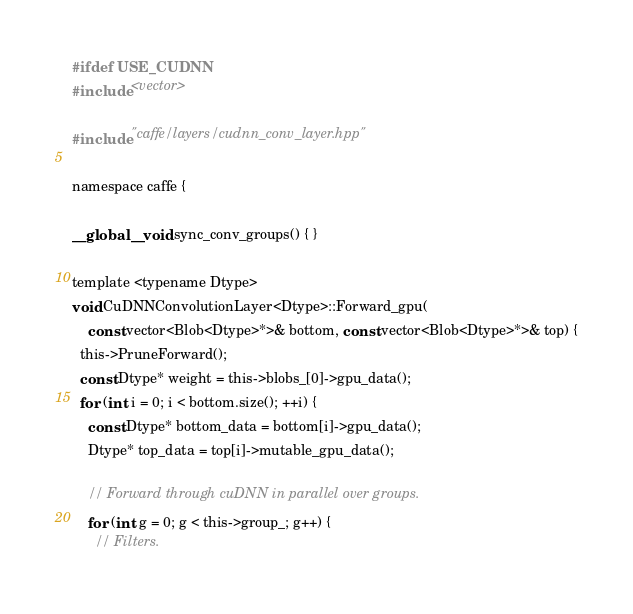Convert code to text. <code><loc_0><loc_0><loc_500><loc_500><_Cuda_>#ifdef USE_CUDNN
#include <vector>

#include "caffe/layers/cudnn_conv_layer.hpp"

namespace caffe {

__global__ void sync_conv_groups() { }

template <typename Dtype>
void CuDNNConvolutionLayer<Dtype>::Forward_gpu(
    const vector<Blob<Dtype>*>& bottom, const vector<Blob<Dtype>*>& top) {
  this->PruneForward();
  const Dtype* weight = this->blobs_[0]->gpu_data();
  for (int i = 0; i < bottom.size(); ++i) {
    const Dtype* bottom_data = bottom[i]->gpu_data();
    Dtype* top_data = top[i]->mutable_gpu_data();

    // Forward through cuDNN in parallel over groups.
    for (int g = 0; g < this->group_; g++) {
      // Filters.</code> 